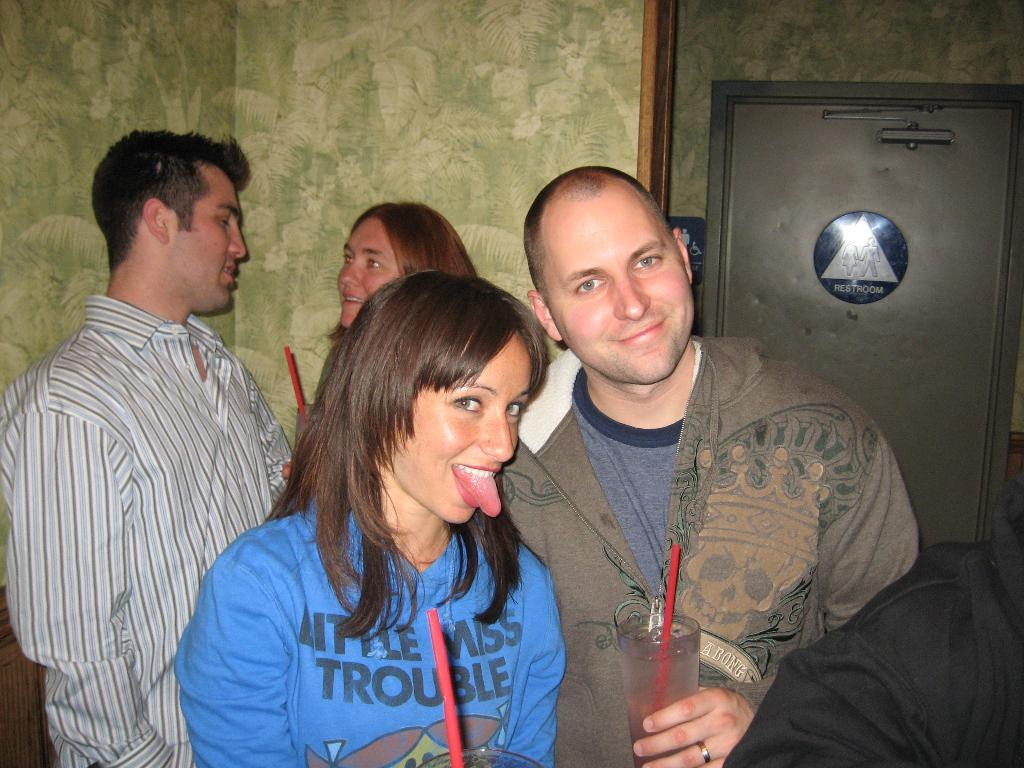Who can be seen in the foreground of the picture? There is a woman and a man in the foreground of the picture. What else can be observed in the background of the image? There is another woman and a man in the background of the picture. What is located on the right side of the image? There is a door on the right side of the image. Whose hand is visible at the bottom of the image? A person's hand is visible at the bottom of the image. What type of riddle is being solved by the people in the image? There is no indication in the image that the people are solving a riddle. How many bells can be heard ringing in the image? There are no bells present in the image, so it is not possible to determine how many might be ringing. 